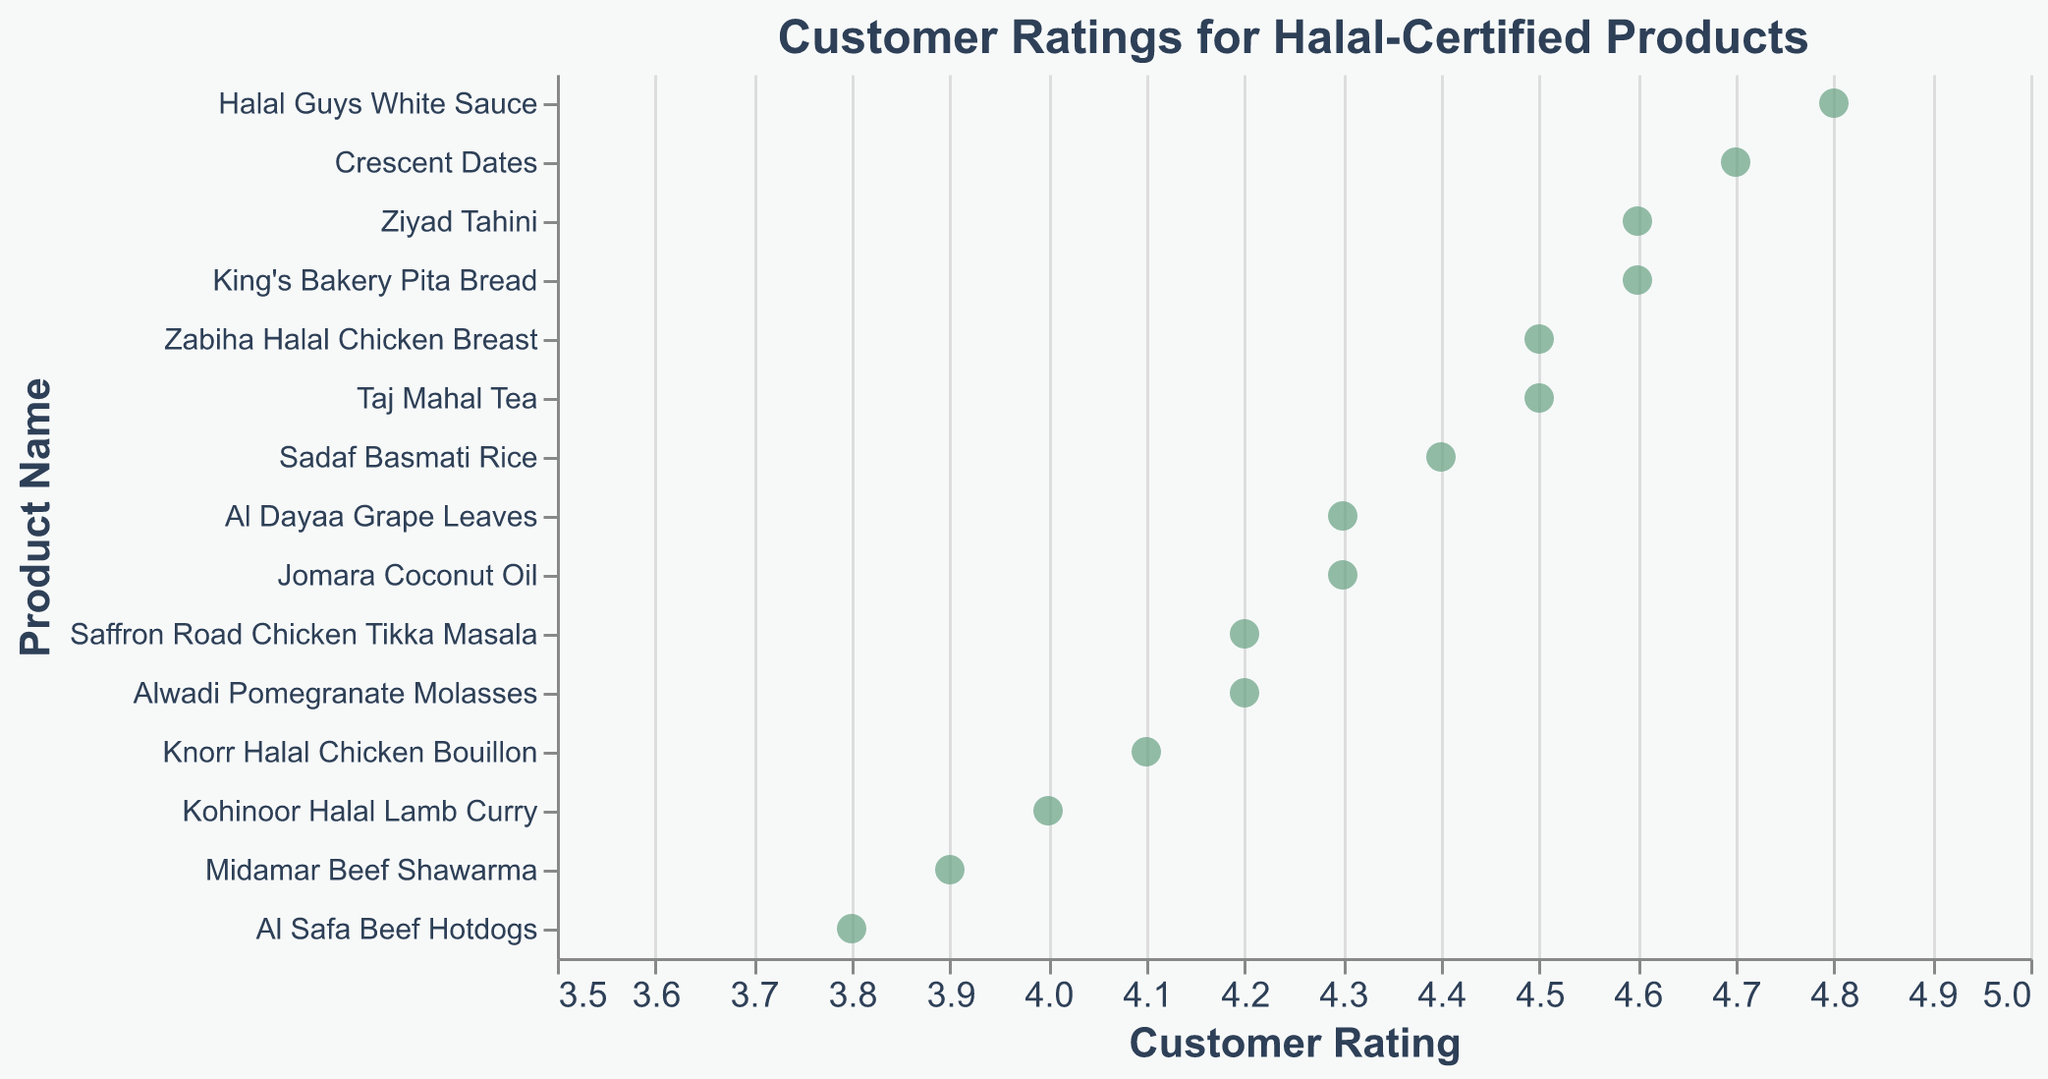What is the title of the figure? The title is displayed at the top of the figure in a certain font size and color, which reads "Customer Ratings for Halal-Certified Products."
Answer: Customer Ratings for Halal-Certified Products What does the x-axis represent? The x-axis is labeled with a title in a specific font, size, and color that reads "Customer Rating." It represents the customer ratings for the products.
Answer: Customer Rating Which product has the highest customer rating? Looking at the data points and their placement on the x-axis, the product with the highest rating (most to the right) is "Halal Guys White Sauce."
Answer: Halal Guys White Sauce How many products have a rating of 4.2? Examining the data points along the x-axis at the 4.2 mark, we see there are two products listed: "Saffron Road Chicken Tikka Masala" and "Alwadi Pomegranate Molasses."
Answer: Two Which product has the lowest customer rating? By looking for the data point closest to the lower end of the x-axis, we see that "Al Safa Beef Hotdogs" has the lowest rating at 3.8.
Answer: Al Safa Beef Hotdogs What is the average rating of all the products? Summing up all individual ratings and dividing by the number of products: (4.5 + 3.8 + 4.7 + 4.2 + 4.6 + 3.9 + 4.1 + 4.8 + 4.3 + 4.4 + 4.0 + 4.5 + 4.2 + 4.6 + 4.3) / 15 = 4.366
Answer: 4.37 How many products have a rating of 4.5? Observing the data points at the 4.5 mark, there are two products: "Zabiha Halal Chicken Breast" and "Taj Mahal Tea."
Answer: Two Which product is rated higher, "Ziyad Tahini" or "Kohinoor Halal Lamb Curry"? Comparing the ratings along the x-axis, "Ziyad Tahini" has a rating of 4.6, while "Kohinoor Halal Lamb Curry" has a rating of 4.0. Thus, "Ziyad Tahini" is rated higher.
Answer: Ziyad Tahini Which products have ratings above 4.5 and what are they? Looking at the x-axis for ratings above 4.5, the products are "Crescent Dates" (4.7), "Halal Guys White Sauce" (4.8), "Ziyad Tahini" (4.6), and "King's Bakery Pita Bread" (4.6).
Answer: Crescent Dates, Halal Guys White Sauce, Ziyad Tahini, King's Bakery Pita Bread What is the difference in ratings between "Midamar Beef Shawarma" and "Knorr Halal Chicken Bouillon"? On the x-axis, "Midamar Beef Shawarma" has a rating of 3.9, and "Knorr Halal Chicken Bouillon" has a rating of 4.1. The difference is computed as 4.1 - 3.9 = 0.2.
Answer: 0.2 